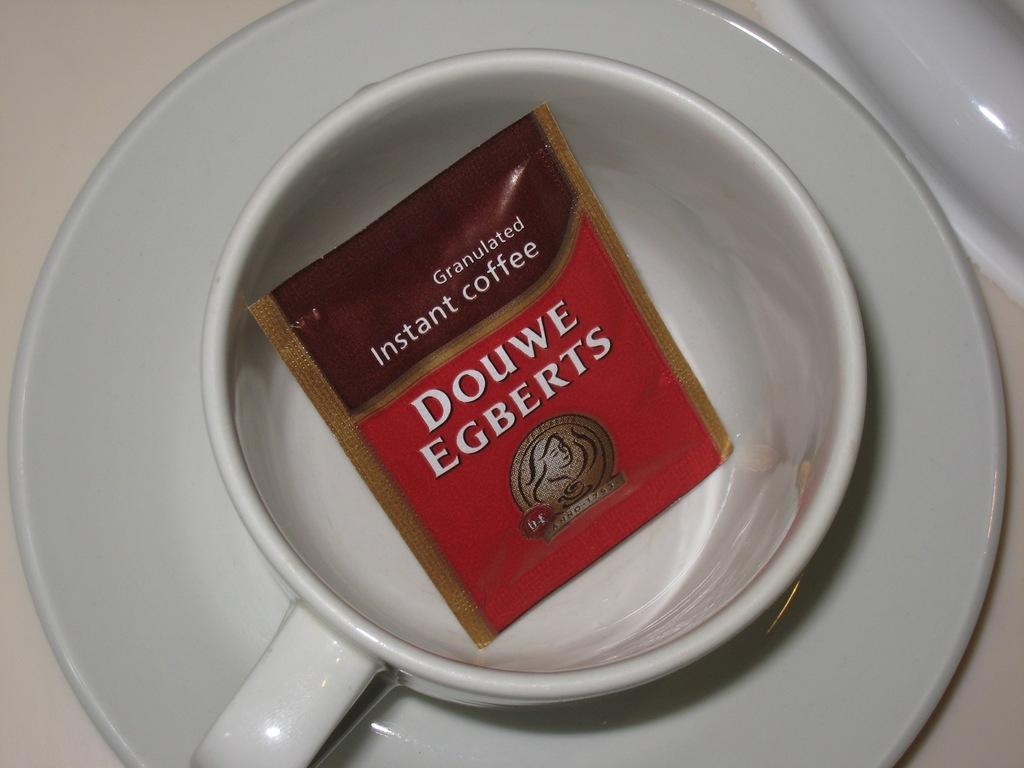Could you give a brief overview of what you see in this image? There is a white color cup and saucer. In side the cup there is a packet with something written on that. 